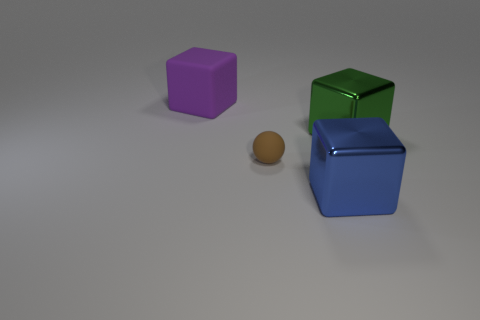Add 3 red metal balls. How many objects exist? 7 Subtract all cubes. How many objects are left? 1 Add 3 large green metallic things. How many large green metallic things exist? 4 Subtract 0 green spheres. How many objects are left? 4 Subtract all blue cubes. Subtract all big green cubes. How many objects are left? 2 Add 1 big purple things. How many big purple things are left? 2 